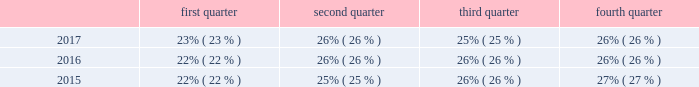Research and development we are committed to investing in highly productive research and development capabilities , particularly in electro-mechanical systems .
Our research and development ( "r&d" ) expenditures were approximately $ 48.3 million , $ 47.3 million and $ 45.2 million for the years ended december 31 , 2017 , 2016 and 2015 , respectively .
We concentrate on developing technology innovations that will deliver growth through the introduction of new products and solutions , and also on driving continuous improvements in product cost , quality , safety and sustainability .
We manage our r&d team as a global group with an emphasis on a global collaborative approach to identify and develop new technologies and worldwide product platforms .
We are organized on a regional basis to leverage expertise in local standards and configurations .
In addition to regional engineering centers in each geographic region , we also operate a global engineering center of excellence in bangalore , india .
Seasonality our business experiences seasonality that varies by product line .
Because more construction and do-it-yourself projects occur during the second and third calendar quarters of each year in the northern hemisphere , our security product sales , typically , are higher in those quarters than in the first and fourth calendar quarters .
However , our interflex business typically experiences higher sales in the fourth calendar quarter due to project timing .
Revenue by quarter for the years ended december 31 , 2017 , 2016 and 2015 are as follows: .
Employees we currently have approximately 10000 employees .
Environmental regulation we have a dedicated environmental program that is designed to reduce the utilization and generation of hazardous materials during the manufacturing process as well as to remediate identified environmental concerns .
As to the latter , we are currently engaged in site investigations and remediation activities to address environmental cleanup from past operations at current and former production facilities .
The company regularly evaluates its remediation programs and considers alternative remediation methods that are in addition to , or in replacement of , those currently utilized by the company based upon enhanced technology and regulatory changes .
We are sometimes a party to environmental lawsuits and claims and have received notices of potential violations of environmental laws and regulations from the u.s .
Environmental protection agency ( the "epa" ) and similar state authorities .
We have also been identified as a potentially responsible party ( "prp" ) for cleanup costs associated with off-site waste disposal at federal superfund and state remediation sites .
For all such sites , there are other prps and , in most instances , our involvement is minimal .
In estimating our liability , we have assumed that we will not bear the entire cost of remediation of any site to the exclusion of other prps who may be jointly and severally liable .
The ability of other prps to participate has been taken into account , based on our understanding of the parties 2019 financial condition and probable contributions on a per site basis .
Additional lawsuits and claims involving environmental matters are likely to arise from time to time in the future .
We incurred $ 3.2 million , $ 23.3 million , and $ 4.4 million of expenses during the years ended december 31 , 2017 , 2016 , and 2015 , respectively , for environmental remediation at sites presently or formerly owned or leased by us .
As of december 31 , 2017 and 2016 , we have recorded reserves for environmental matters of $ 28.9 million and $ 30.6 million .
Of these amounts $ 8.9 million and $ 9.6 million , respectively , relate to remediation of sites previously disposed by us .
Given the evolving nature of environmental laws , regulations and technology , the ultimate cost of future compliance is uncertain. .
Considering the years 2016-2017 , what is the increase observed in the research and development expenditures? 
Rationale: it is the value of the expenditures in 2017 divided by the 2016's , then turned into a percentage to represent the increase .
Computations: ((48.3 / 47.3) - 1)
Answer: 0.02114. 